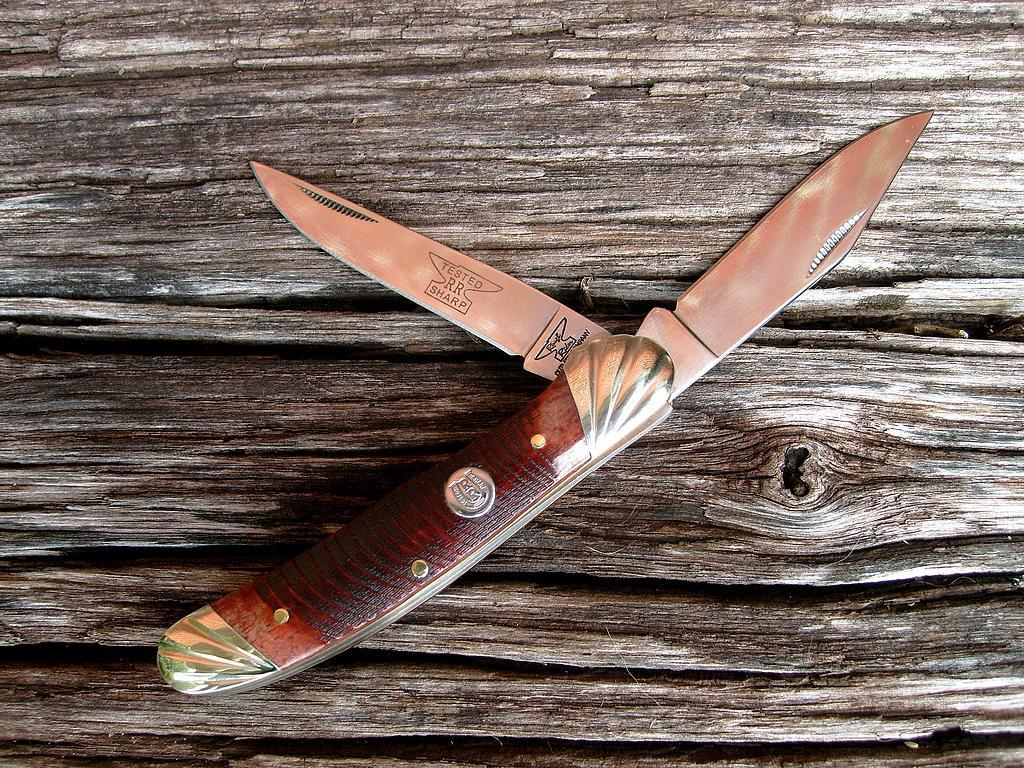What object is visible on the table in the image? There is a knife visible in the image. Can you describe the location of the knife in the image? The knife is on a table. Can you see any goats or lumber at the seashore in the image? There is no seashore, goats, or lumber present in the image. 